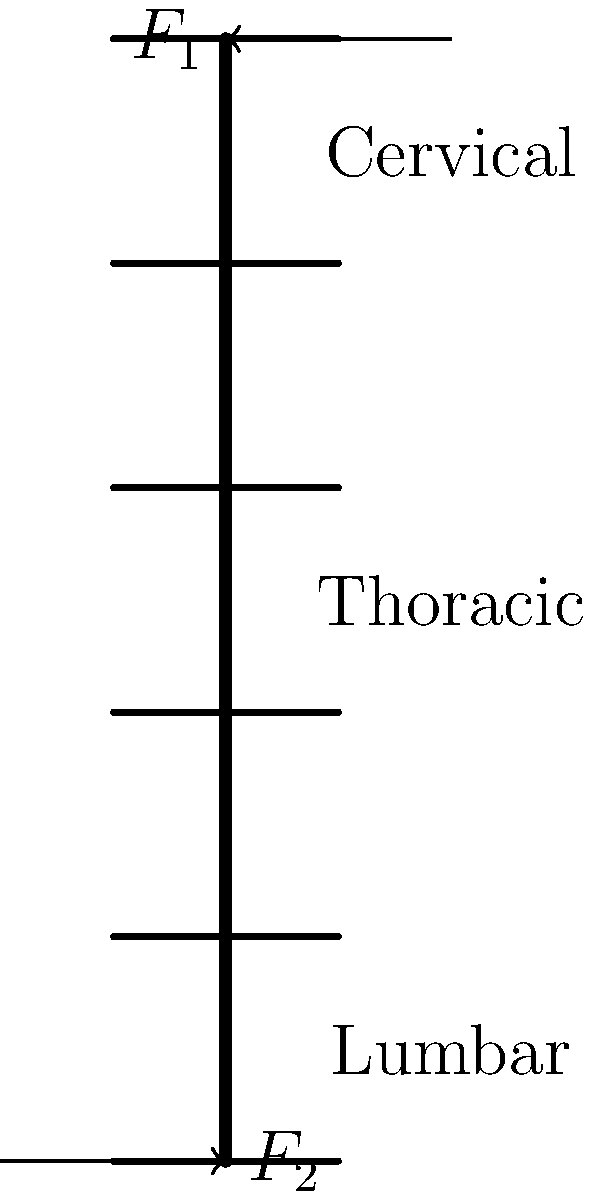In a simplified model of an astronaut's spine during long-term microgravity exposure, the spinal column is represented as a straight column with forces $F_1$ and $F_2$ applied at the top and bottom, respectively. If the spine has a length of 70 cm and the force $F_1$ is 50 N, what should be the magnitude of $F_2$ to maintain the spine in equilibrium, assuming no other forces are acting on it? To solve this problem, we need to apply the principles of static equilibrium to the simplified spinal column model. Here's a step-by-step explanation:

1. In static equilibrium, the sum of all forces must be zero:
   $$\sum F = 0$$

2. In this case, we have two forces acting on the spine: $F_1$ acting downward at the top and $F_2$ acting upward at the bottom.

3. For equilibrium in the vertical direction:
   $$F_2 - F_1 = 0$$

4. We are given that $F_1 = 50$ N, so we can substitute this value:
   $$F_2 - 50 = 0$$

5. Solving for $F_2$:
   $$F_2 = 50 \text{ N}$$

6. The magnitude of $F_2$ must be equal to $F_1$ but in the opposite direction to maintain equilibrium.

Note: The length of the spine (70 cm) is not directly used in this calculation, as we are only concerned with the balance of forces, not moments. In a more complex model, the spine's length and curvature would be relevant for analyzing stress distribution and potential deformation.
Answer: 50 N 